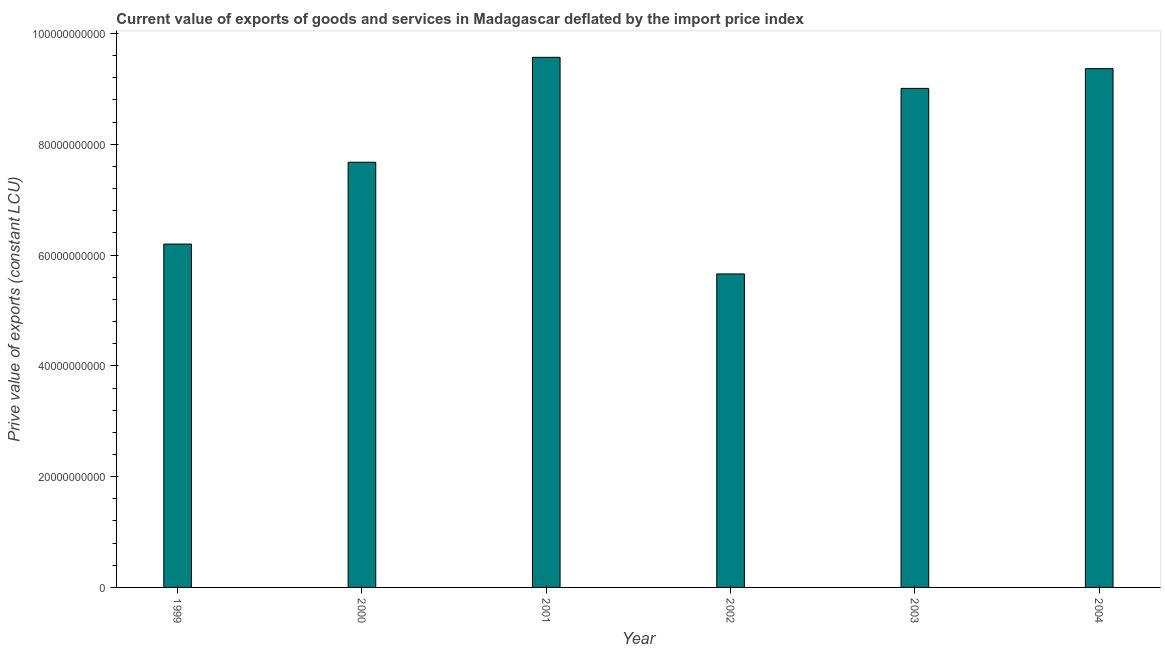What is the title of the graph?
Offer a terse response. Current value of exports of goods and services in Madagascar deflated by the import price index. What is the label or title of the X-axis?
Ensure brevity in your answer.  Year. What is the label or title of the Y-axis?
Your answer should be very brief. Prive value of exports (constant LCU). What is the price value of exports in 2004?
Keep it short and to the point. 9.36e+1. Across all years, what is the maximum price value of exports?
Your answer should be compact. 9.57e+1. Across all years, what is the minimum price value of exports?
Make the answer very short. 5.66e+1. What is the sum of the price value of exports?
Your answer should be very brief. 4.75e+11. What is the difference between the price value of exports in 1999 and 2002?
Offer a terse response. 5.39e+09. What is the average price value of exports per year?
Ensure brevity in your answer.  7.91e+1. What is the median price value of exports?
Provide a short and direct response. 8.34e+1. Do a majority of the years between 1999 and 2004 (inclusive) have price value of exports greater than 68000000000 LCU?
Give a very brief answer. Yes. What is the ratio of the price value of exports in 2000 to that in 2001?
Your response must be concise. 0.8. Is the difference between the price value of exports in 2000 and 2003 greater than the difference between any two years?
Provide a succinct answer. No. What is the difference between the highest and the second highest price value of exports?
Provide a succinct answer. 2.05e+09. What is the difference between the highest and the lowest price value of exports?
Keep it short and to the point. 3.91e+1. In how many years, is the price value of exports greater than the average price value of exports taken over all years?
Provide a succinct answer. 3. How many bars are there?
Provide a succinct answer. 6. Are all the bars in the graph horizontal?
Give a very brief answer. No. What is the difference between two consecutive major ticks on the Y-axis?
Provide a succinct answer. 2.00e+1. What is the Prive value of exports (constant LCU) in 1999?
Make the answer very short. 6.20e+1. What is the Prive value of exports (constant LCU) of 2000?
Make the answer very short. 7.68e+1. What is the Prive value of exports (constant LCU) in 2001?
Ensure brevity in your answer.  9.57e+1. What is the Prive value of exports (constant LCU) in 2002?
Give a very brief answer. 5.66e+1. What is the Prive value of exports (constant LCU) in 2003?
Offer a terse response. 9.01e+1. What is the Prive value of exports (constant LCU) in 2004?
Offer a very short reply. 9.36e+1. What is the difference between the Prive value of exports (constant LCU) in 1999 and 2000?
Your answer should be very brief. -1.48e+1. What is the difference between the Prive value of exports (constant LCU) in 1999 and 2001?
Your answer should be compact. -3.37e+1. What is the difference between the Prive value of exports (constant LCU) in 1999 and 2002?
Provide a short and direct response. 5.39e+09. What is the difference between the Prive value of exports (constant LCU) in 1999 and 2003?
Offer a terse response. -2.81e+1. What is the difference between the Prive value of exports (constant LCU) in 1999 and 2004?
Offer a very short reply. -3.17e+1. What is the difference between the Prive value of exports (constant LCU) in 2000 and 2001?
Ensure brevity in your answer.  -1.89e+1. What is the difference between the Prive value of exports (constant LCU) in 2000 and 2002?
Your answer should be very brief. 2.02e+1. What is the difference between the Prive value of exports (constant LCU) in 2000 and 2003?
Your answer should be very brief. -1.33e+1. What is the difference between the Prive value of exports (constant LCU) in 2000 and 2004?
Provide a short and direct response. -1.69e+1. What is the difference between the Prive value of exports (constant LCU) in 2001 and 2002?
Keep it short and to the point. 3.91e+1. What is the difference between the Prive value of exports (constant LCU) in 2001 and 2003?
Offer a terse response. 5.61e+09. What is the difference between the Prive value of exports (constant LCU) in 2001 and 2004?
Give a very brief answer. 2.05e+09. What is the difference between the Prive value of exports (constant LCU) in 2002 and 2003?
Your answer should be compact. -3.35e+1. What is the difference between the Prive value of exports (constant LCU) in 2002 and 2004?
Keep it short and to the point. -3.71e+1. What is the difference between the Prive value of exports (constant LCU) in 2003 and 2004?
Your answer should be compact. -3.56e+09. What is the ratio of the Prive value of exports (constant LCU) in 1999 to that in 2000?
Provide a short and direct response. 0.81. What is the ratio of the Prive value of exports (constant LCU) in 1999 to that in 2001?
Your answer should be very brief. 0.65. What is the ratio of the Prive value of exports (constant LCU) in 1999 to that in 2002?
Offer a very short reply. 1.09. What is the ratio of the Prive value of exports (constant LCU) in 1999 to that in 2003?
Your answer should be compact. 0.69. What is the ratio of the Prive value of exports (constant LCU) in 1999 to that in 2004?
Provide a short and direct response. 0.66. What is the ratio of the Prive value of exports (constant LCU) in 2000 to that in 2001?
Provide a short and direct response. 0.8. What is the ratio of the Prive value of exports (constant LCU) in 2000 to that in 2002?
Provide a short and direct response. 1.36. What is the ratio of the Prive value of exports (constant LCU) in 2000 to that in 2003?
Make the answer very short. 0.85. What is the ratio of the Prive value of exports (constant LCU) in 2000 to that in 2004?
Your answer should be very brief. 0.82. What is the ratio of the Prive value of exports (constant LCU) in 2001 to that in 2002?
Offer a very short reply. 1.69. What is the ratio of the Prive value of exports (constant LCU) in 2001 to that in 2003?
Keep it short and to the point. 1.06. What is the ratio of the Prive value of exports (constant LCU) in 2001 to that in 2004?
Ensure brevity in your answer.  1.02. What is the ratio of the Prive value of exports (constant LCU) in 2002 to that in 2003?
Your answer should be compact. 0.63. What is the ratio of the Prive value of exports (constant LCU) in 2002 to that in 2004?
Ensure brevity in your answer.  0.6. 